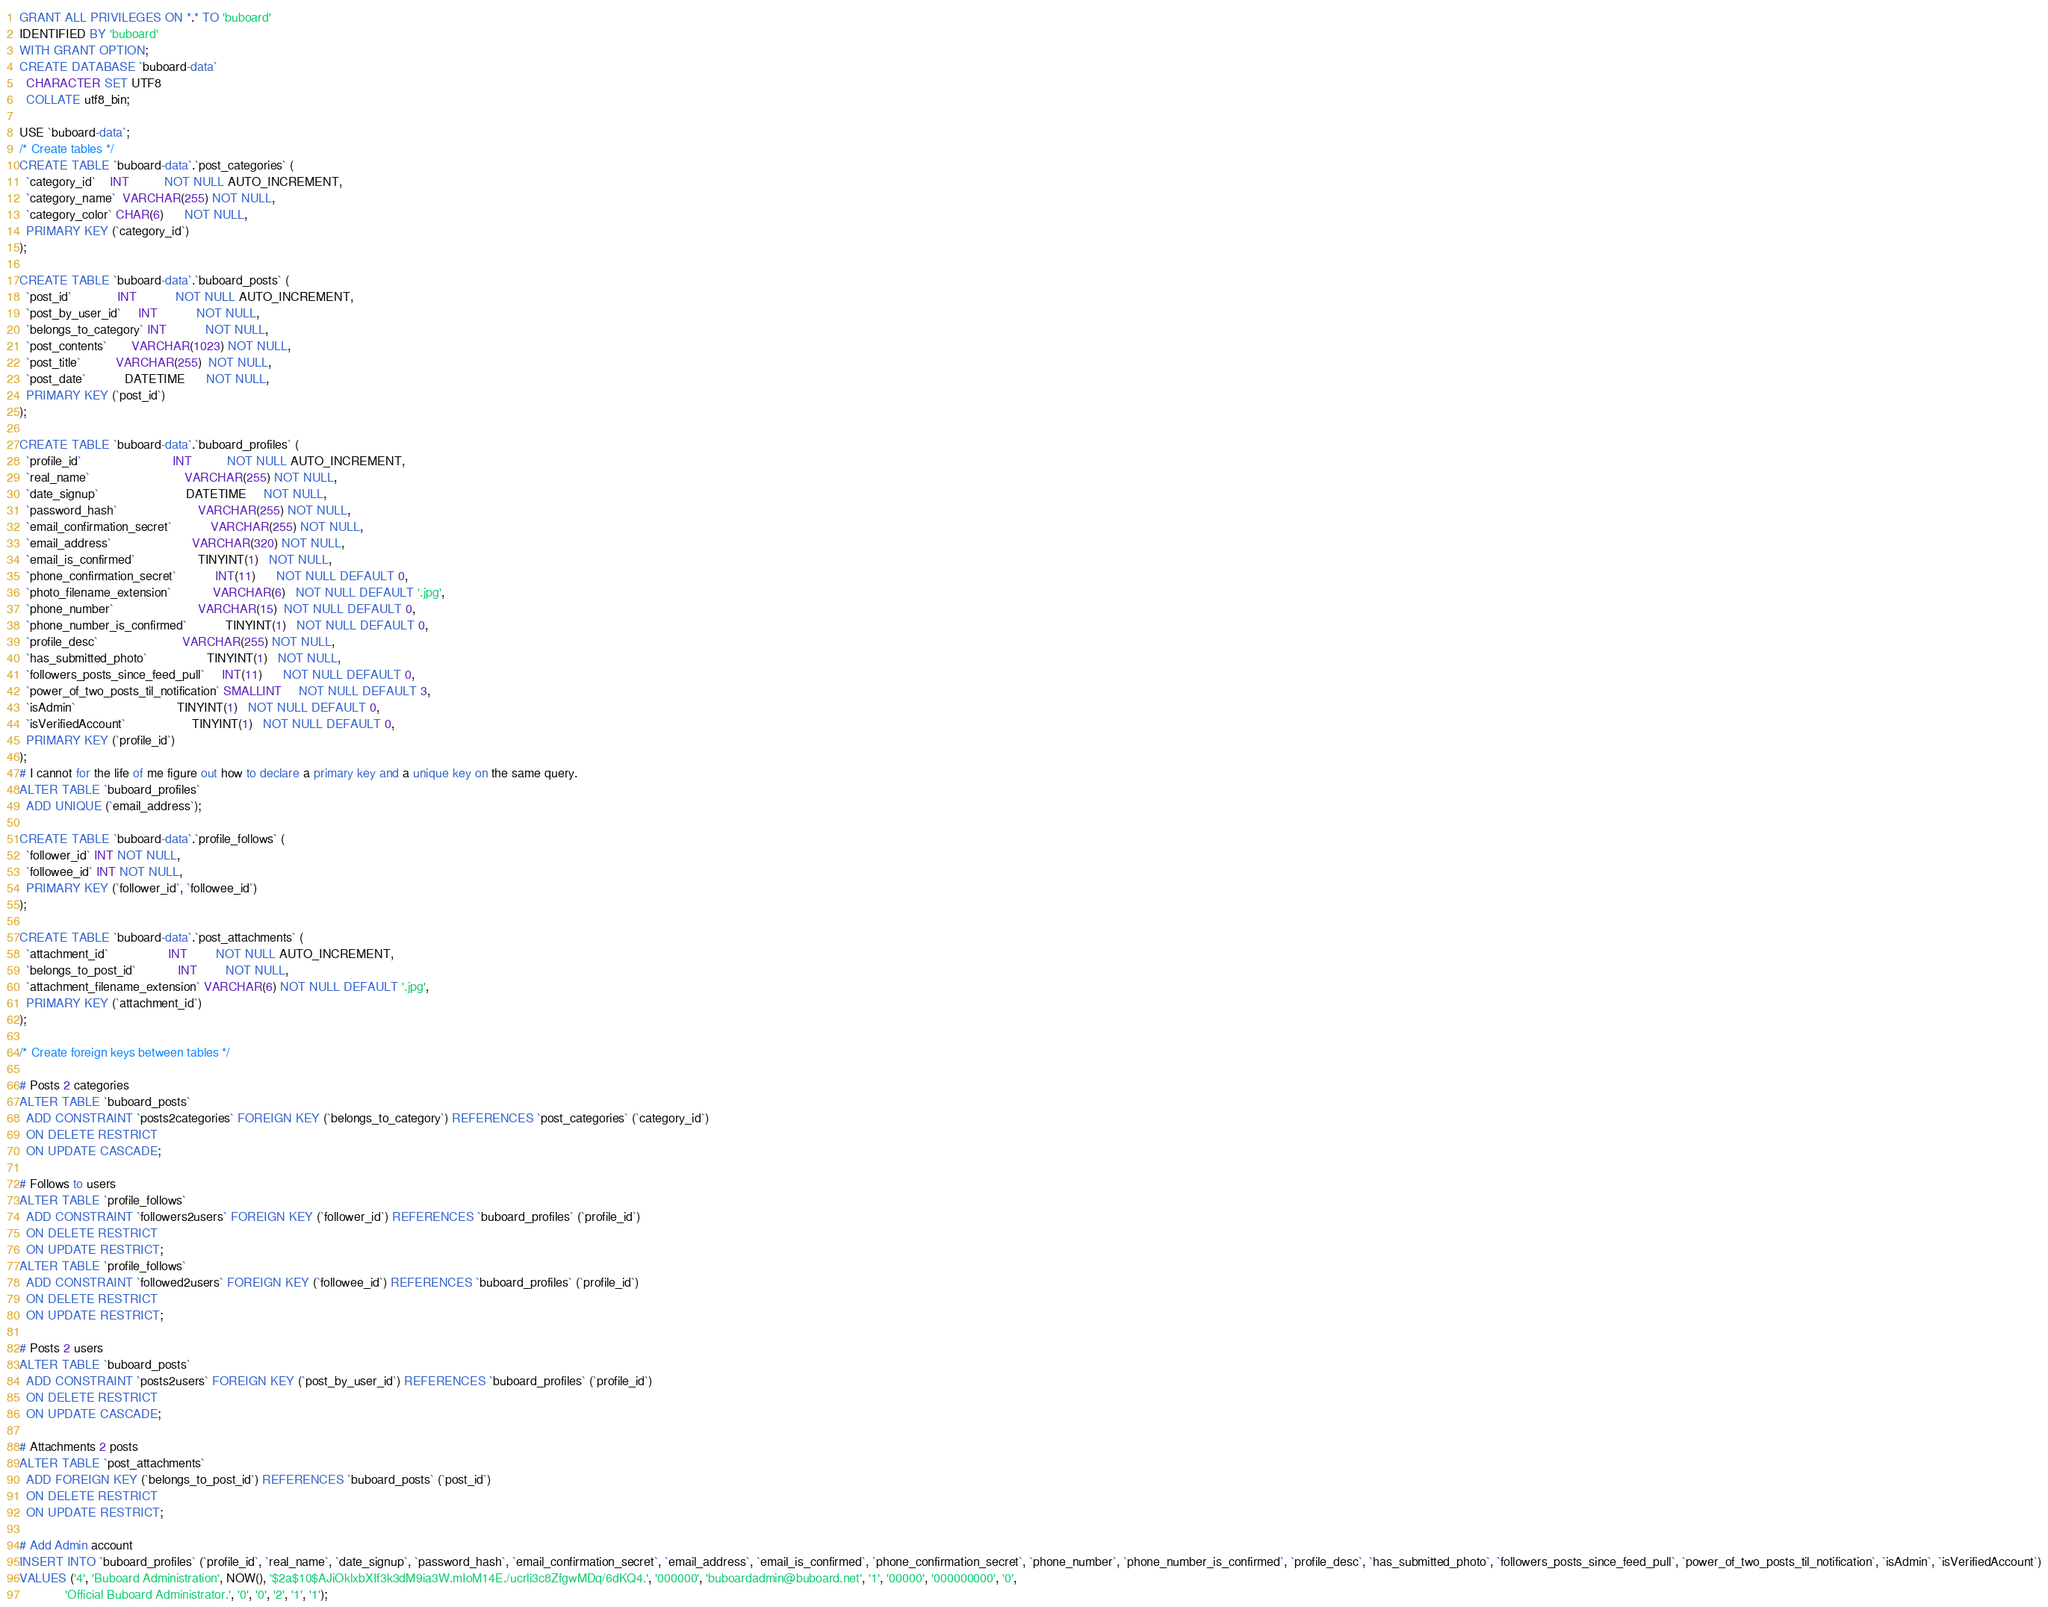<code> <loc_0><loc_0><loc_500><loc_500><_SQL_>GRANT ALL PRIVILEGES ON *.* TO 'buboard'
IDENTIFIED BY 'buboard'
WITH GRANT OPTION;
CREATE DATABASE `buboard-data`
  CHARACTER SET UTF8
  COLLATE utf8_bin;

USE `buboard-data`;
/* Create tables */
CREATE TABLE `buboard-data`.`post_categories` (
  `category_id`    INT          NOT NULL AUTO_INCREMENT,
  `category_name`  VARCHAR(255) NOT NULL,
  `category_color` CHAR(6)      NOT NULL,
  PRIMARY KEY (`category_id`)
);

CREATE TABLE `buboard-data`.`buboard_posts` (
  `post_id`             INT           NOT NULL AUTO_INCREMENT,
  `post_by_user_id`     INT           NOT NULL,
  `belongs_to_category` INT           NOT NULL,
  `post_contents`       VARCHAR(1023) NOT NULL,
  `post_title`          VARCHAR(255)  NOT NULL,
  `post_date`           DATETIME      NOT NULL,
  PRIMARY KEY (`post_id`)
);

CREATE TABLE `buboard-data`.`buboard_profiles` (
  `profile_id`                          INT          NOT NULL AUTO_INCREMENT,
  `real_name`                           VARCHAR(255) NOT NULL,
  `date_signup`                         DATETIME     NOT NULL,
  `password_hash`                       VARCHAR(255) NOT NULL,
  `email_confirmation_secret`           VARCHAR(255) NOT NULL,
  `email_address`                       VARCHAR(320) NOT NULL,
  `email_is_confirmed`                  TINYINT(1)   NOT NULL,
  `phone_confirmation_secret`           INT(11)      NOT NULL DEFAULT 0,
  `photo_filename_extension`            VARCHAR(6)   NOT NULL DEFAULT '.jpg',
  `phone_number`                        VARCHAR(15)  NOT NULL DEFAULT 0,
  `phone_number_is_confirmed`           TINYINT(1)   NOT NULL DEFAULT 0,
  `profile_desc`                        VARCHAR(255) NOT NULL,
  `has_submitted_photo`                 TINYINT(1)   NOT NULL,
  `followers_posts_since_feed_pull`     INT(11)      NOT NULL DEFAULT 0,
  `power_of_two_posts_til_notification` SMALLINT     NOT NULL DEFAULT 3,
  `isAdmin`                             TINYINT(1)   NOT NULL DEFAULT 0,
  `isVerifiedAccount`                   TINYINT(1)   NOT NULL DEFAULT 0,
  PRIMARY KEY (`profile_id`)
);
# I cannot for the life of me figure out how to declare a primary key and a unique key on the same query.
ALTER TABLE `buboard_profiles`
  ADD UNIQUE (`email_address`);

CREATE TABLE `buboard-data`.`profile_follows` (
  `follower_id` INT NOT NULL,
  `followee_id` INT NOT NULL,
  PRIMARY KEY (`follower_id`, `followee_id`)
);

CREATE TABLE `buboard-data`.`post_attachments` (
  `attachment_id`                 INT        NOT NULL AUTO_INCREMENT,
  `belongs_to_post_id`            INT        NOT NULL,
  `attachment_filename_extension` VARCHAR(6) NOT NULL DEFAULT '.jpg',
  PRIMARY KEY (`attachment_id`)
);

/* Create foreign keys between tables */

# Posts 2 categories
ALTER TABLE `buboard_posts`
  ADD CONSTRAINT `posts2categories` FOREIGN KEY (`belongs_to_category`) REFERENCES `post_categories` (`category_id`)
  ON DELETE RESTRICT
  ON UPDATE CASCADE;

# Follows to users
ALTER TABLE `profile_follows`
  ADD CONSTRAINT `followers2users` FOREIGN KEY (`follower_id`) REFERENCES `buboard_profiles` (`profile_id`)
  ON DELETE RESTRICT
  ON UPDATE RESTRICT;
ALTER TABLE `profile_follows`
  ADD CONSTRAINT `followed2users` FOREIGN KEY (`followee_id`) REFERENCES `buboard_profiles` (`profile_id`)
  ON DELETE RESTRICT
  ON UPDATE RESTRICT;

# Posts 2 users
ALTER TABLE `buboard_posts`
  ADD CONSTRAINT `posts2users` FOREIGN KEY (`post_by_user_id`) REFERENCES `buboard_profiles` (`profile_id`)
  ON DELETE RESTRICT
  ON UPDATE CASCADE;

# Attachments 2 posts
ALTER TABLE `post_attachments`
  ADD FOREIGN KEY (`belongs_to_post_id`) REFERENCES `buboard_posts` (`post_id`)
  ON DELETE RESTRICT
  ON UPDATE RESTRICT;

# Add Admin account
INSERT INTO `buboard_profiles` (`profile_id`, `real_name`, `date_signup`, `password_hash`, `email_confirmation_secret`, `email_address`, `email_is_confirmed`, `phone_confirmation_secret`, `phone_number`, `phone_number_is_confirmed`, `profile_desc`, `has_submitted_photo`, `followers_posts_since_feed_pull`, `power_of_two_posts_til_notification`, `isAdmin`, `isVerifiedAccount`)
VALUES ('4', 'Buboard Administration', NOW(), '$2a$10$AJiOklxbXIf3k3dM9ia3W.mIoM14E./ucrli3c8ZfgwMDq/6dKQ4.', '000000', 'buboardadmin@buboard.net', '1', '00000', '000000000', '0',
             'Official Buboard Administrator.', '0', '0', '2', '1', '1');</code> 